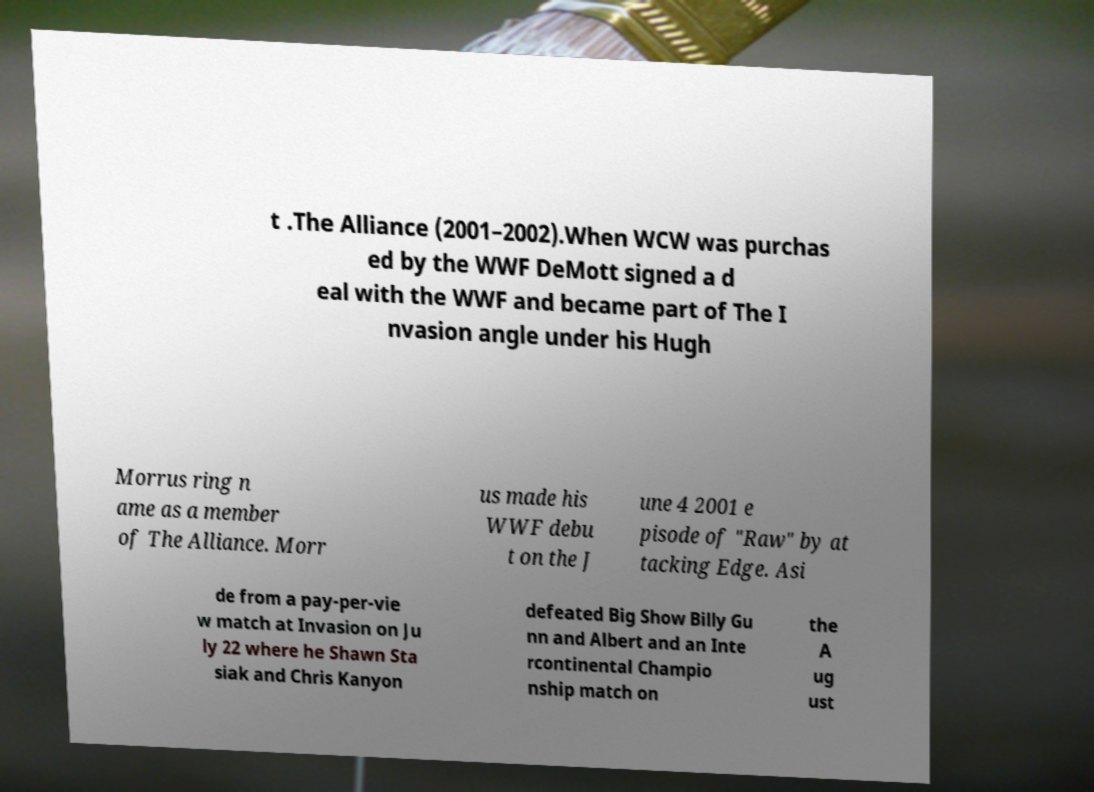Please read and relay the text visible in this image. What does it say? t .The Alliance (2001–2002).When WCW was purchas ed by the WWF DeMott signed a d eal with the WWF and became part of The I nvasion angle under his Hugh Morrus ring n ame as a member of The Alliance. Morr us made his WWF debu t on the J une 4 2001 e pisode of "Raw" by at tacking Edge. Asi de from a pay-per-vie w match at Invasion on Ju ly 22 where he Shawn Sta siak and Chris Kanyon defeated Big Show Billy Gu nn and Albert and an Inte rcontinental Champio nship match on the A ug ust 